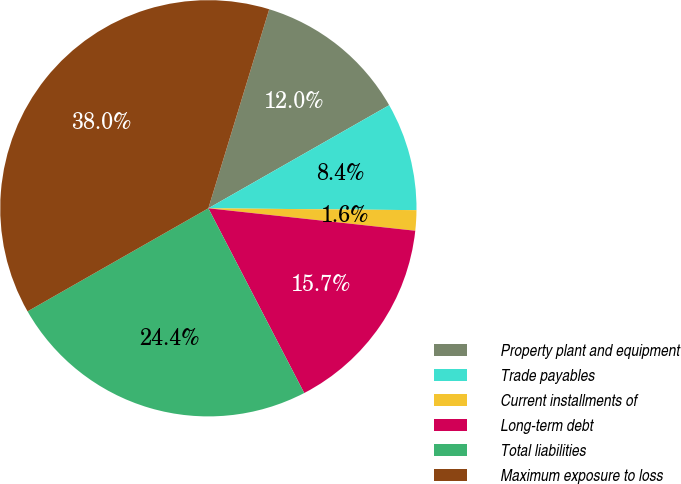Convert chart to OTSL. <chart><loc_0><loc_0><loc_500><loc_500><pie_chart><fcel>Property plant and equipment<fcel>Trade payables<fcel>Current installments of<fcel>Long-term debt<fcel>Total liabilities<fcel>Maximum exposure to loss<nl><fcel>12.03%<fcel>8.39%<fcel>1.58%<fcel>15.66%<fcel>24.37%<fcel>37.97%<nl></chart> 